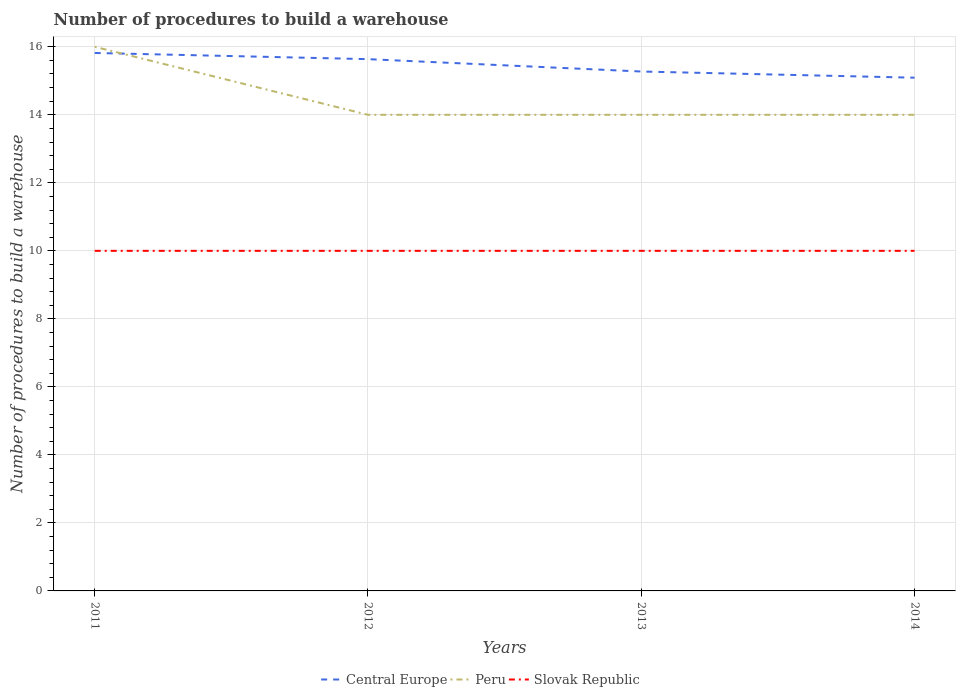How many different coloured lines are there?
Your answer should be very brief. 3. Across all years, what is the maximum number of procedures to build a warehouse in in Central Europe?
Offer a very short reply. 15.09. In which year was the number of procedures to build a warehouse in in Slovak Republic maximum?
Offer a terse response. 2011. What is the total number of procedures to build a warehouse in in Central Europe in the graph?
Ensure brevity in your answer.  0.18. What is the difference between the highest and the second highest number of procedures to build a warehouse in in Slovak Republic?
Offer a very short reply. 0. Is the number of procedures to build a warehouse in in Slovak Republic strictly greater than the number of procedures to build a warehouse in in Central Europe over the years?
Your answer should be compact. Yes. Does the graph contain grids?
Make the answer very short. Yes. How many legend labels are there?
Keep it short and to the point. 3. What is the title of the graph?
Provide a succinct answer. Number of procedures to build a warehouse. Does "Turkmenistan" appear as one of the legend labels in the graph?
Provide a short and direct response. No. What is the label or title of the X-axis?
Keep it short and to the point. Years. What is the label or title of the Y-axis?
Provide a short and direct response. Number of procedures to build a warehouse. What is the Number of procedures to build a warehouse in Central Europe in 2011?
Provide a succinct answer. 15.82. What is the Number of procedures to build a warehouse in Peru in 2011?
Offer a terse response. 16. What is the Number of procedures to build a warehouse in Central Europe in 2012?
Your answer should be very brief. 15.64. What is the Number of procedures to build a warehouse of Slovak Republic in 2012?
Offer a very short reply. 10. What is the Number of procedures to build a warehouse in Central Europe in 2013?
Keep it short and to the point. 15.27. What is the Number of procedures to build a warehouse of Peru in 2013?
Make the answer very short. 14. What is the Number of procedures to build a warehouse of Central Europe in 2014?
Your answer should be compact. 15.09. What is the Number of procedures to build a warehouse in Peru in 2014?
Your answer should be very brief. 14. Across all years, what is the maximum Number of procedures to build a warehouse in Central Europe?
Your response must be concise. 15.82. Across all years, what is the maximum Number of procedures to build a warehouse in Slovak Republic?
Ensure brevity in your answer.  10. Across all years, what is the minimum Number of procedures to build a warehouse of Central Europe?
Provide a short and direct response. 15.09. Across all years, what is the minimum Number of procedures to build a warehouse of Peru?
Offer a very short reply. 14. What is the total Number of procedures to build a warehouse of Central Europe in the graph?
Keep it short and to the point. 61.82. What is the total Number of procedures to build a warehouse of Slovak Republic in the graph?
Give a very brief answer. 40. What is the difference between the Number of procedures to build a warehouse of Central Europe in 2011 and that in 2012?
Offer a terse response. 0.18. What is the difference between the Number of procedures to build a warehouse in Peru in 2011 and that in 2012?
Ensure brevity in your answer.  2. What is the difference between the Number of procedures to build a warehouse of Slovak Republic in 2011 and that in 2012?
Give a very brief answer. 0. What is the difference between the Number of procedures to build a warehouse of Central Europe in 2011 and that in 2013?
Provide a succinct answer. 0.55. What is the difference between the Number of procedures to build a warehouse of Peru in 2011 and that in 2013?
Provide a short and direct response. 2. What is the difference between the Number of procedures to build a warehouse in Central Europe in 2011 and that in 2014?
Ensure brevity in your answer.  0.73. What is the difference between the Number of procedures to build a warehouse of Peru in 2011 and that in 2014?
Your answer should be compact. 2. What is the difference between the Number of procedures to build a warehouse of Central Europe in 2012 and that in 2013?
Ensure brevity in your answer.  0.36. What is the difference between the Number of procedures to build a warehouse in Central Europe in 2012 and that in 2014?
Give a very brief answer. 0.55. What is the difference between the Number of procedures to build a warehouse in Peru in 2012 and that in 2014?
Offer a terse response. 0. What is the difference between the Number of procedures to build a warehouse of Central Europe in 2013 and that in 2014?
Offer a terse response. 0.18. What is the difference between the Number of procedures to build a warehouse of Peru in 2013 and that in 2014?
Ensure brevity in your answer.  0. What is the difference between the Number of procedures to build a warehouse of Slovak Republic in 2013 and that in 2014?
Your response must be concise. 0. What is the difference between the Number of procedures to build a warehouse in Central Europe in 2011 and the Number of procedures to build a warehouse in Peru in 2012?
Your answer should be very brief. 1.82. What is the difference between the Number of procedures to build a warehouse of Central Europe in 2011 and the Number of procedures to build a warehouse of Slovak Republic in 2012?
Keep it short and to the point. 5.82. What is the difference between the Number of procedures to build a warehouse of Peru in 2011 and the Number of procedures to build a warehouse of Slovak Republic in 2012?
Provide a short and direct response. 6. What is the difference between the Number of procedures to build a warehouse of Central Europe in 2011 and the Number of procedures to build a warehouse of Peru in 2013?
Your answer should be compact. 1.82. What is the difference between the Number of procedures to build a warehouse of Central Europe in 2011 and the Number of procedures to build a warehouse of Slovak Republic in 2013?
Your response must be concise. 5.82. What is the difference between the Number of procedures to build a warehouse in Peru in 2011 and the Number of procedures to build a warehouse in Slovak Republic in 2013?
Give a very brief answer. 6. What is the difference between the Number of procedures to build a warehouse in Central Europe in 2011 and the Number of procedures to build a warehouse in Peru in 2014?
Keep it short and to the point. 1.82. What is the difference between the Number of procedures to build a warehouse in Central Europe in 2011 and the Number of procedures to build a warehouse in Slovak Republic in 2014?
Offer a terse response. 5.82. What is the difference between the Number of procedures to build a warehouse of Peru in 2011 and the Number of procedures to build a warehouse of Slovak Republic in 2014?
Provide a short and direct response. 6. What is the difference between the Number of procedures to build a warehouse of Central Europe in 2012 and the Number of procedures to build a warehouse of Peru in 2013?
Give a very brief answer. 1.64. What is the difference between the Number of procedures to build a warehouse in Central Europe in 2012 and the Number of procedures to build a warehouse in Slovak Republic in 2013?
Provide a short and direct response. 5.64. What is the difference between the Number of procedures to build a warehouse of Central Europe in 2012 and the Number of procedures to build a warehouse of Peru in 2014?
Your answer should be compact. 1.64. What is the difference between the Number of procedures to build a warehouse of Central Europe in 2012 and the Number of procedures to build a warehouse of Slovak Republic in 2014?
Ensure brevity in your answer.  5.64. What is the difference between the Number of procedures to build a warehouse in Central Europe in 2013 and the Number of procedures to build a warehouse in Peru in 2014?
Your response must be concise. 1.27. What is the difference between the Number of procedures to build a warehouse of Central Europe in 2013 and the Number of procedures to build a warehouse of Slovak Republic in 2014?
Provide a short and direct response. 5.27. What is the difference between the Number of procedures to build a warehouse of Peru in 2013 and the Number of procedures to build a warehouse of Slovak Republic in 2014?
Make the answer very short. 4. What is the average Number of procedures to build a warehouse in Central Europe per year?
Your answer should be very brief. 15.45. What is the average Number of procedures to build a warehouse in Peru per year?
Your answer should be compact. 14.5. What is the average Number of procedures to build a warehouse of Slovak Republic per year?
Provide a succinct answer. 10. In the year 2011, what is the difference between the Number of procedures to build a warehouse in Central Europe and Number of procedures to build a warehouse in Peru?
Ensure brevity in your answer.  -0.18. In the year 2011, what is the difference between the Number of procedures to build a warehouse in Central Europe and Number of procedures to build a warehouse in Slovak Republic?
Your answer should be compact. 5.82. In the year 2012, what is the difference between the Number of procedures to build a warehouse of Central Europe and Number of procedures to build a warehouse of Peru?
Your answer should be very brief. 1.64. In the year 2012, what is the difference between the Number of procedures to build a warehouse of Central Europe and Number of procedures to build a warehouse of Slovak Republic?
Offer a very short reply. 5.64. In the year 2012, what is the difference between the Number of procedures to build a warehouse of Peru and Number of procedures to build a warehouse of Slovak Republic?
Make the answer very short. 4. In the year 2013, what is the difference between the Number of procedures to build a warehouse in Central Europe and Number of procedures to build a warehouse in Peru?
Offer a very short reply. 1.27. In the year 2013, what is the difference between the Number of procedures to build a warehouse of Central Europe and Number of procedures to build a warehouse of Slovak Republic?
Give a very brief answer. 5.27. In the year 2014, what is the difference between the Number of procedures to build a warehouse of Central Europe and Number of procedures to build a warehouse of Slovak Republic?
Ensure brevity in your answer.  5.09. In the year 2014, what is the difference between the Number of procedures to build a warehouse in Peru and Number of procedures to build a warehouse in Slovak Republic?
Give a very brief answer. 4. What is the ratio of the Number of procedures to build a warehouse in Central Europe in 2011 to that in 2012?
Your answer should be compact. 1.01. What is the ratio of the Number of procedures to build a warehouse in Slovak Republic in 2011 to that in 2012?
Your response must be concise. 1. What is the ratio of the Number of procedures to build a warehouse of Central Europe in 2011 to that in 2013?
Provide a short and direct response. 1.04. What is the ratio of the Number of procedures to build a warehouse in Slovak Republic in 2011 to that in 2013?
Offer a terse response. 1. What is the ratio of the Number of procedures to build a warehouse of Central Europe in 2011 to that in 2014?
Offer a very short reply. 1.05. What is the ratio of the Number of procedures to build a warehouse of Peru in 2011 to that in 2014?
Give a very brief answer. 1.14. What is the ratio of the Number of procedures to build a warehouse in Central Europe in 2012 to that in 2013?
Ensure brevity in your answer.  1.02. What is the ratio of the Number of procedures to build a warehouse in Peru in 2012 to that in 2013?
Offer a very short reply. 1. What is the ratio of the Number of procedures to build a warehouse in Central Europe in 2012 to that in 2014?
Keep it short and to the point. 1.04. What is the ratio of the Number of procedures to build a warehouse of Peru in 2012 to that in 2014?
Your answer should be very brief. 1. What is the ratio of the Number of procedures to build a warehouse of Slovak Republic in 2012 to that in 2014?
Offer a terse response. 1. What is the ratio of the Number of procedures to build a warehouse in Central Europe in 2013 to that in 2014?
Keep it short and to the point. 1.01. What is the difference between the highest and the second highest Number of procedures to build a warehouse in Central Europe?
Your response must be concise. 0.18. What is the difference between the highest and the second highest Number of procedures to build a warehouse of Peru?
Offer a terse response. 2. What is the difference between the highest and the lowest Number of procedures to build a warehouse in Central Europe?
Your answer should be very brief. 0.73. What is the difference between the highest and the lowest Number of procedures to build a warehouse in Peru?
Keep it short and to the point. 2. What is the difference between the highest and the lowest Number of procedures to build a warehouse of Slovak Republic?
Keep it short and to the point. 0. 